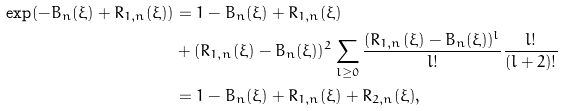<formula> <loc_0><loc_0><loc_500><loc_500>\exp ( - B _ { n } ( \xi ) + R _ { 1 , n } ( \xi ) ) & = 1 - B _ { n } ( \xi ) + R _ { 1 , n } ( \xi ) \\ & + ( R _ { 1 , n } ( \xi ) - B _ { n } ( \xi ) ) ^ { 2 } \sum _ { l \geq 0 } \frac { ( R _ { 1 , n } ( \xi ) - B _ { n } ( \xi ) ) ^ { l } } { l ! } \frac { l ! } { ( l + 2 ) ! } \\ & = 1 - B _ { n } ( \xi ) + R _ { 1 , n } ( \xi ) + R _ { 2 , n } ( \xi ) ,</formula> 